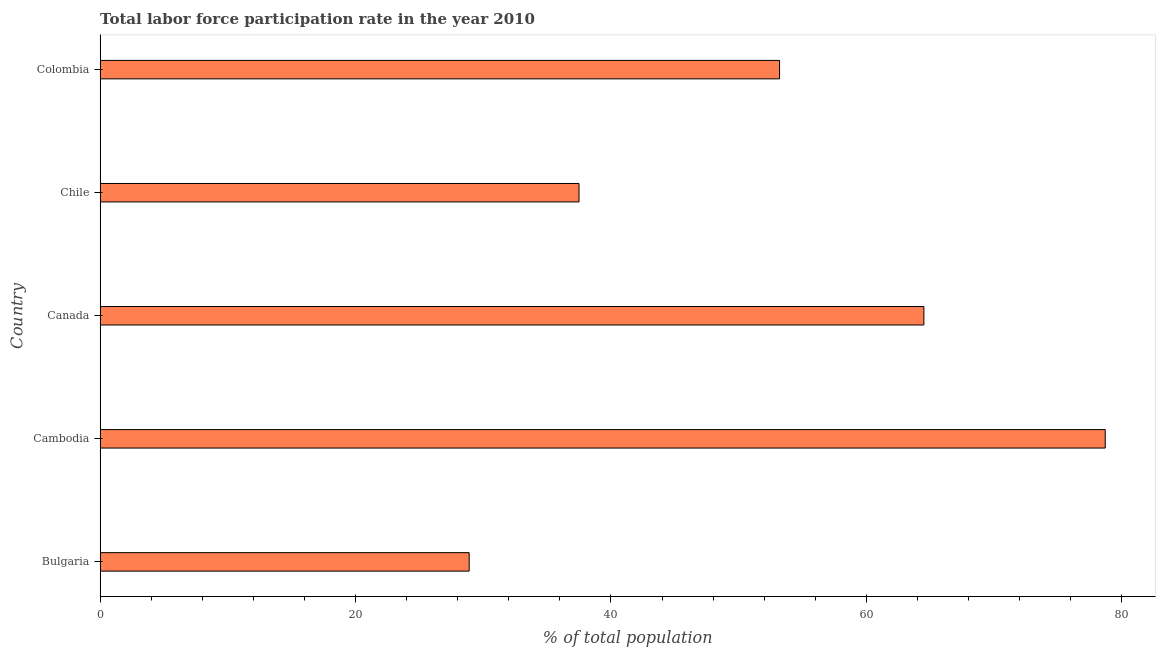Does the graph contain any zero values?
Your answer should be compact. No. What is the title of the graph?
Your response must be concise. Total labor force participation rate in the year 2010. What is the label or title of the X-axis?
Provide a short and direct response. % of total population. What is the label or title of the Y-axis?
Offer a very short reply. Country. What is the total labor force participation rate in Canada?
Provide a short and direct response. 64.5. Across all countries, what is the maximum total labor force participation rate?
Your answer should be compact. 78.7. Across all countries, what is the minimum total labor force participation rate?
Keep it short and to the point. 28.9. In which country was the total labor force participation rate maximum?
Make the answer very short. Cambodia. What is the sum of the total labor force participation rate?
Make the answer very short. 262.8. What is the average total labor force participation rate per country?
Offer a very short reply. 52.56. What is the median total labor force participation rate?
Give a very brief answer. 53.2. What is the ratio of the total labor force participation rate in Bulgaria to that in Canada?
Offer a very short reply. 0.45. Is the total labor force participation rate in Bulgaria less than that in Chile?
Keep it short and to the point. Yes. What is the difference between the highest and the second highest total labor force participation rate?
Your response must be concise. 14.2. Is the sum of the total labor force participation rate in Chile and Colombia greater than the maximum total labor force participation rate across all countries?
Provide a short and direct response. Yes. What is the difference between the highest and the lowest total labor force participation rate?
Give a very brief answer. 49.8. How many bars are there?
Provide a short and direct response. 5. Are all the bars in the graph horizontal?
Make the answer very short. Yes. What is the difference between two consecutive major ticks on the X-axis?
Make the answer very short. 20. What is the % of total population in Bulgaria?
Your answer should be compact. 28.9. What is the % of total population in Cambodia?
Offer a terse response. 78.7. What is the % of total population in Canada?
Your response must be concise. 64.5. What is the % of total population of Chile?
Your answer should be compact. 37.5. What is the % of total population of Colombia?
Provide a short and direct response. 53.2. What is the difference between the % of total population in Bulgaria and Cambodia?
Offer a very short reply. -49.8. What is the difference between the % of total population in Bulgaria and Canada?
Keep it short and to the point. -35.6. What is the difference between the % of total population in Bulgaria and Colombia?
Give a very brief answer. -24.3. What is the difference between the % of total population in Cambodia and Canada?
Your response must be concise. 14.2. What is the difference between the % of total population in Cambodia and Chile?
Your answer should be compact. 41.2. What is the difference between the % of total population in Canada and Chile?
Offer a terse response. 27. What is the difference between the % of total population in Chile and Colombia?
Offer a terse response. -15.7. What is the ratio of the % of total population in Bulgaria to that in Cambodia?
Offer a terse response. 0.37. What is the ratio of the % of total population in Bulgaria to that in Canada?
Give a very brief answer. 0.45. What is the ratio of the % of total population in Bulgaria to that in Chile?
Give a very brief answer. 0.77. What is the ratio of the % of total population in Bulgaria to that in Colombia?
Ensure brevity in your answer.  0.54. What is the ratio of the % of total population in Cambodia to that in Canada?
Make the answer very short. 1.22. What is the ratio of the % of total population in Cambodia to that in Chile?
Ensure brevity in your answer.  2.1. What is the ratio of the % of total population in Cambodia to that in Colombia?
Your answer should be compact. 1.48. What is the ratio of the % of total population in Canada to that in Chile?
Provide a short and direct response. 1.72. What is the ratio of the % of total population in Canada to that in Colombia?
Make the answer very short. 1.21. What is the ratio of the % of total population in Chile to that in Colombia?
Provide a succinct answer. 0.7. 